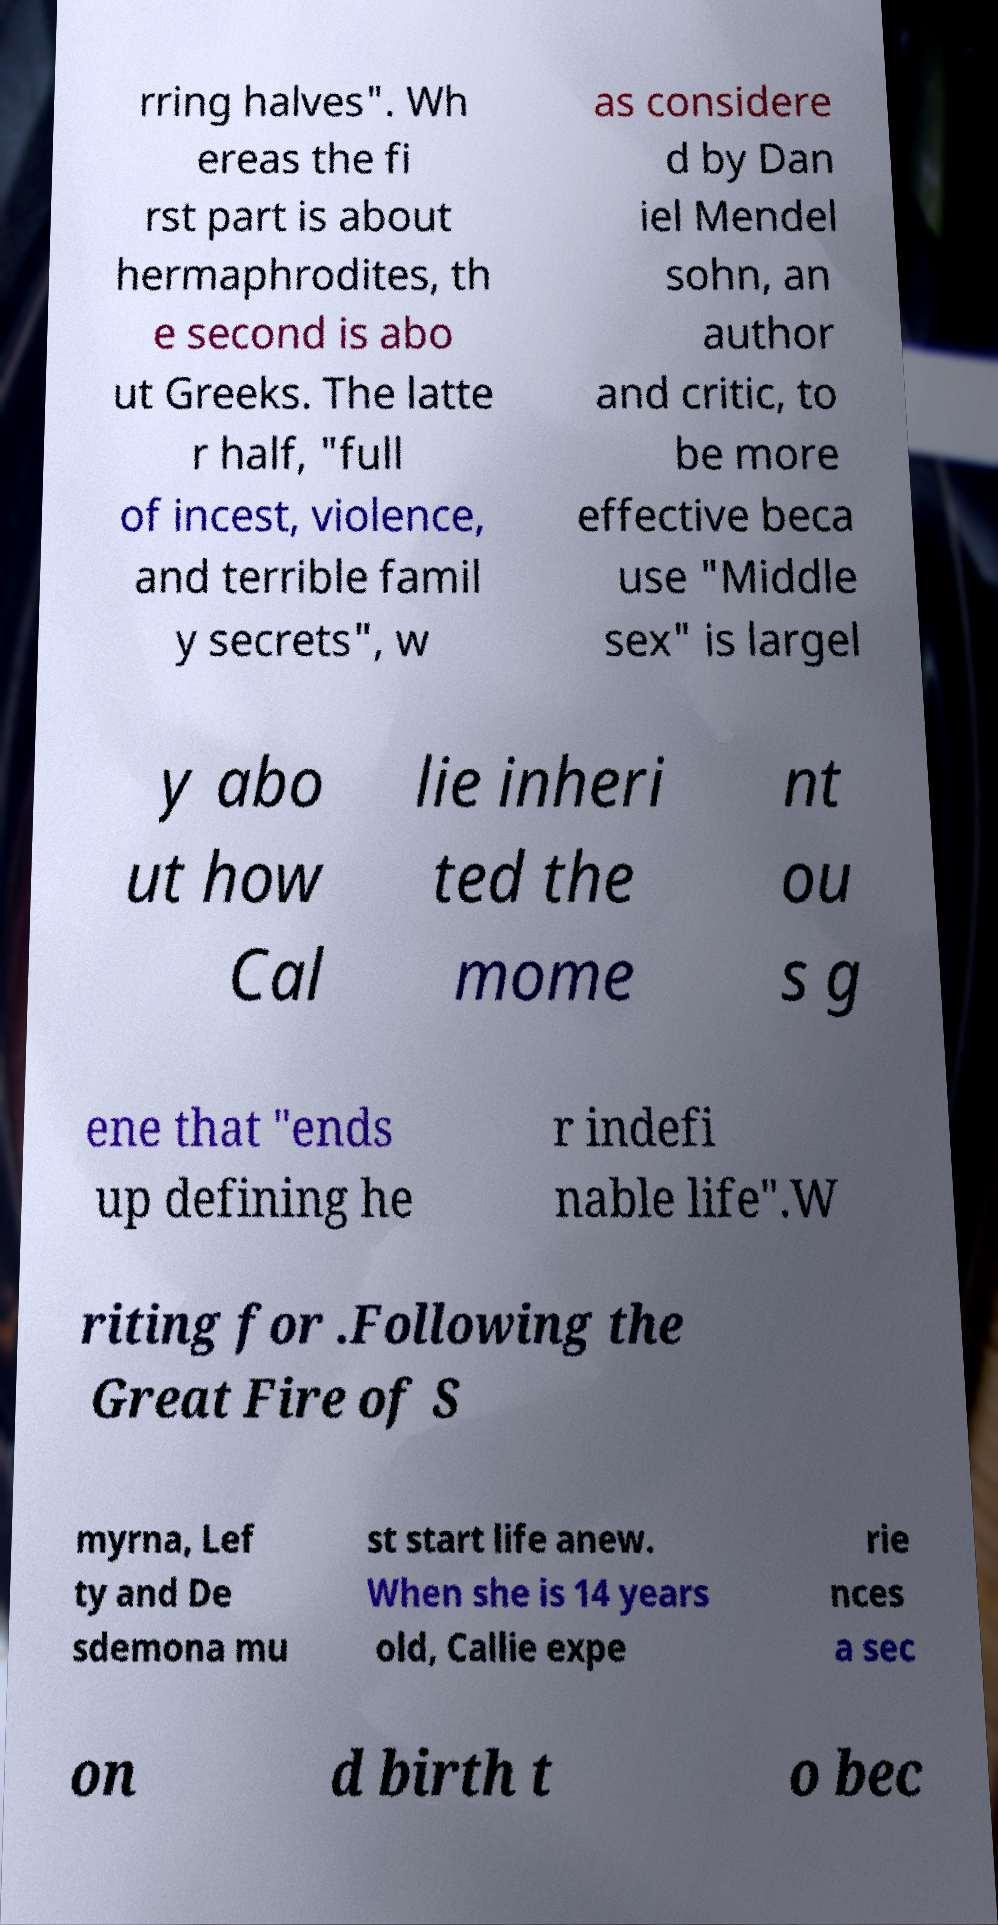Please read and relay the text visible in this image. What does it say? rring halves". Wh ereas the fi rst part is about hermaphrodites, th e second is abo ut Greeks. The latte r half, "full of incest, violence, and terrible famil y secrets", w as considere d by Dan iel Mendel sohn, an author and critic, to be more effective beca use "Middle sex" is largel y abo ut how Cal lie inheri ted the mome nt ou s g ene that "ends up defining he r indefi nable life".W riting for .Following the Great Fire of S myrna, Lef ty and De sdemona mu st start life anew. When she is 14 years old, Callie expe rie nces a sec on d birth t o bec 